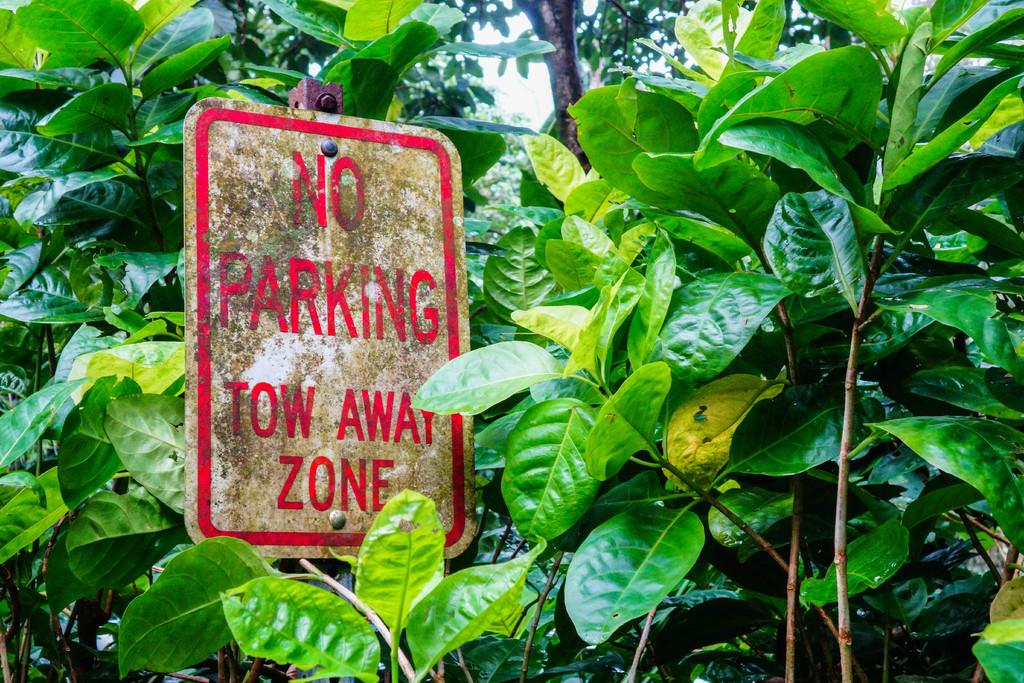What is attached to the pole in the image? There is a board fixed to a pole in the image. What color is the text on the board? The board has red text on it. What can be seen in the background of the image? There are plants and trees in the background of the image. Where is the rat sitting and enjoying its lunch in the image? There is no rat or lunch present in the image. 